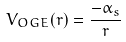<formula> <loc_0><loc_0><loc_500><loc_500>V _ { O G E } ( r ) = \frac { - \alpha _ { s } } { r }</formula> 